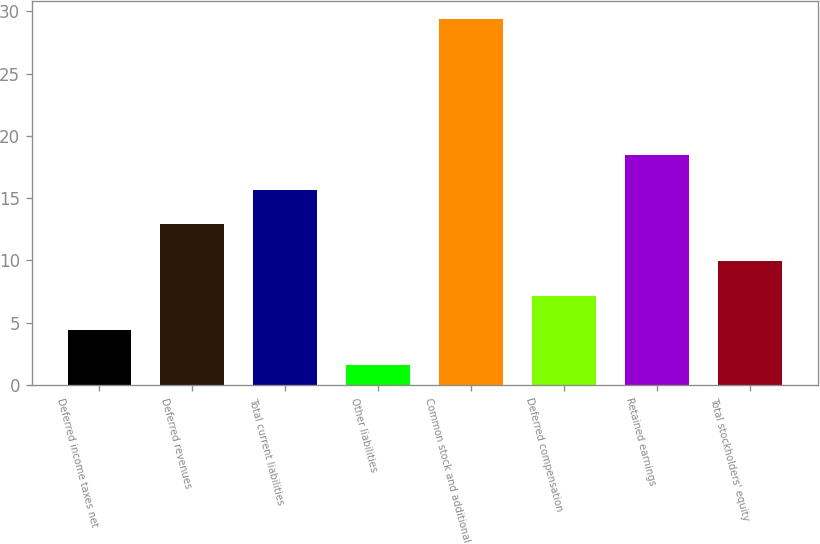Convert chart. <chart><loc_0><loc_0><loc_500><loc_500><bar_chart><fcel>Deferred income taxes net<fcel>Deferred revenues<fcel>Total current liabilities<fcel>Other liabilities<fcel>Common stock and additional<fcel>Deferred compensation<fcel>Retained earnings<fcel>Total stockholders' equity<nl><fcel>4.4<fcel>12.9<fcel>15.68<fcel>1.6<fcel>29.4<fcel>7.18<fcel>18.46<fcel>9.96<nl></chart> 